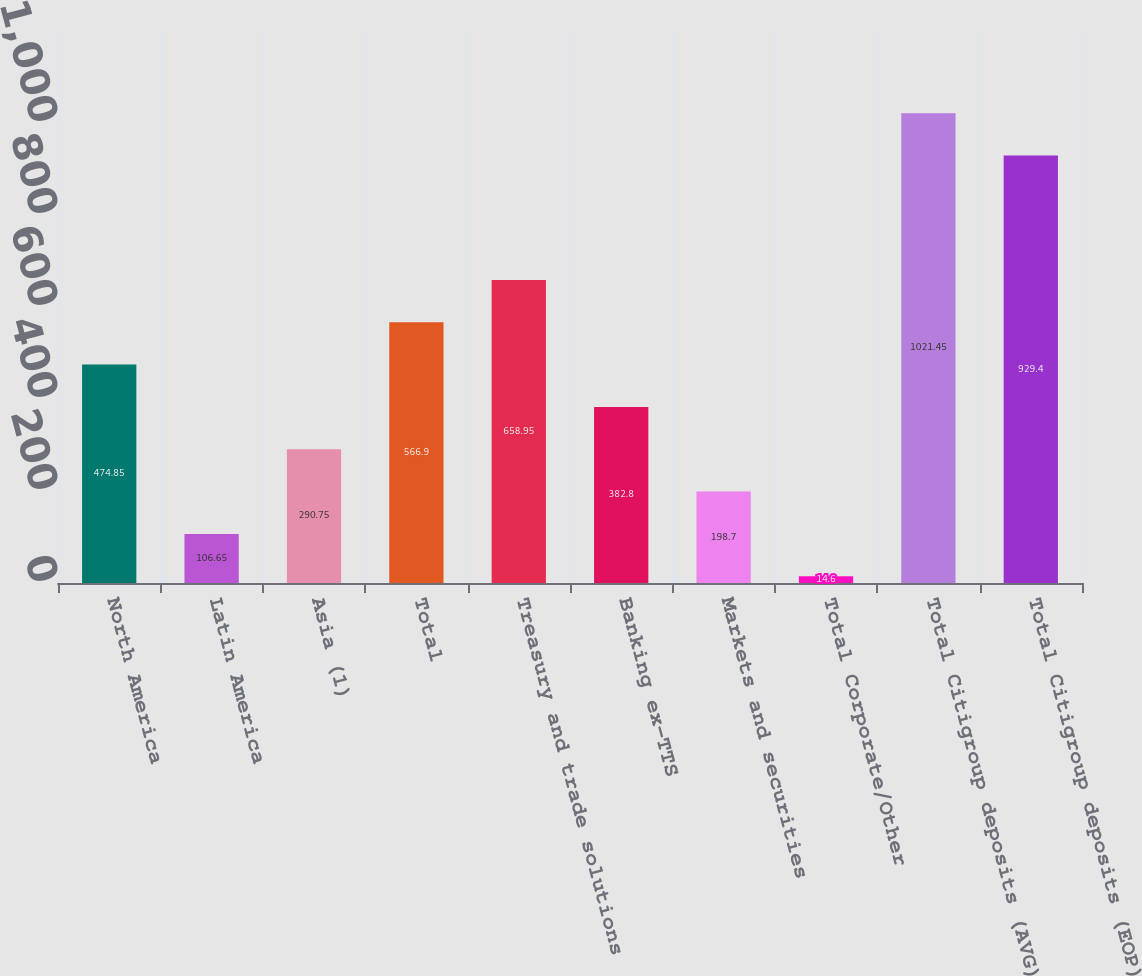<chart> <loc_0><loc_0><loc_500><loc_500><bar_chart><fcel>North America<fcel>Latin America<fcel>Asia (1)<fcel>Total<fcel>Treasury and trade solutions<fcel>Banking ex-TTS<fcel>Markets and securities<fcel>Total Corporate/Other<fcel>Total Citigroup deposits (AVG)<fcel>Total Citigroup deposits (EOP)<nl><fcel>474.85<fcel>106.65<fcel>290.75<fcel>566.9<fcel>658.95<fcel>382.8<fcel>198.7<fcel>14.6<fcel>1021.45<fcel>929.4<nl></chart> 